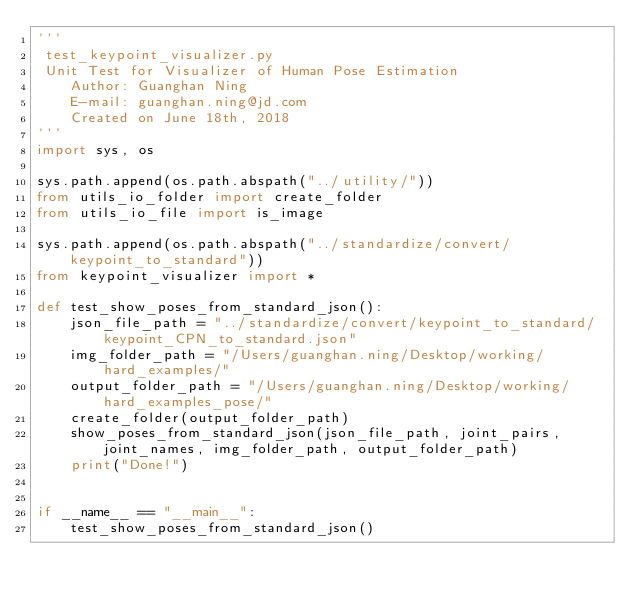<code> <loc_0><loc_0><loc_500><loc_500><_Python_>'''
 test_keypoint_visualizer.py
 Unit Test for Visualizer of Human Pose Estimation
    Author: Guanghan Ning
    E-mail: guanghan.ning@jd.com
    Created on June 18th, 2018
'''
import sys, os

sys.path.append(os.path.abspath("../utility/"))
from utils_io_folder import create_folder
from utils_io_file import is_image

sys.path.append(os.path.abspath("../standardize/convert/keypoint_to_standard"))
from keypoint_visualizer import *

def test_show_poses_from_standard_json():
    json_file_path = "../standardize/convert/keypoint_to_standard/keypoint_CPN_to_standard.json"
    img_folder_path = "/Users/guanghan.ning/Desktop/working/hard_examples/"
    output_folder_path = "/Users/guanghan.ning/Desktop/working/hard_examples_pose/"
    create_folder(output_folder_path)
    show_poses_from_standard_json(json_file_path, joint_pairs, joint_names, img_folder_path, output_folder_path)
    print("Done!")


if __name__ == "__main__":
    test_show_poses_from_standard_json()
</code> 